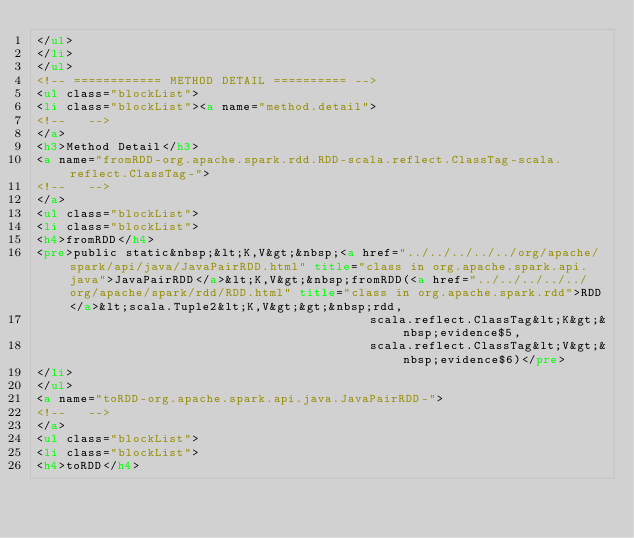<code> <loc_0><loc_0><loc_500><loc_500><_HTML_></ul>
</li>
</ul>
<!-- ============ METHOD DETAIL ========== -->
<ul class="blockList">
<li class="blockList"><a name="method.detail">
<!--   -->
</a>
<h3>Method Detail</h3>
<a name="fromRDD-org.apache.spark.rdd.RDD-scala.reflect.ClassTag-scala.reflect.ClassTag-">
<!--   -->
</a>
<ul class="blockList">
<li class="blockList">
<h4>fromRDD</h4>
<pre>public static&nbsp;&lt;K,V&gt;&nbsp;<a href="../../../../../org/apache/spark/api/java/JavaPairRDD.html" title="class in org.apache.spark.api.java">JavaPairRDD</a>&lt;K,V&gt;&nbsp;fromRDD(<a href="../../../../../org/apache/spark/rdd/RDD.html" title="class in org.apache.spark.rdd">RDD</a>&lt;scala.Tuple2&lt;K,V&gt;&gt;&nbsp;rdd,
                                             scala.reflect.ClassTag&lt;K&gt;&nbsp;evidence$5,
                                             scala.reflect.ClassTag&lt;V&gt;&nbsp;evidence$6)</pre>
</li>
</ul>
<a name="toRDD-org.apache.spark.api.java.JavaPairRDD-">
<!--   -->
</a>
<ul class="blockList">
<li class="blockList">
<h4>toRDD</h4></code> 